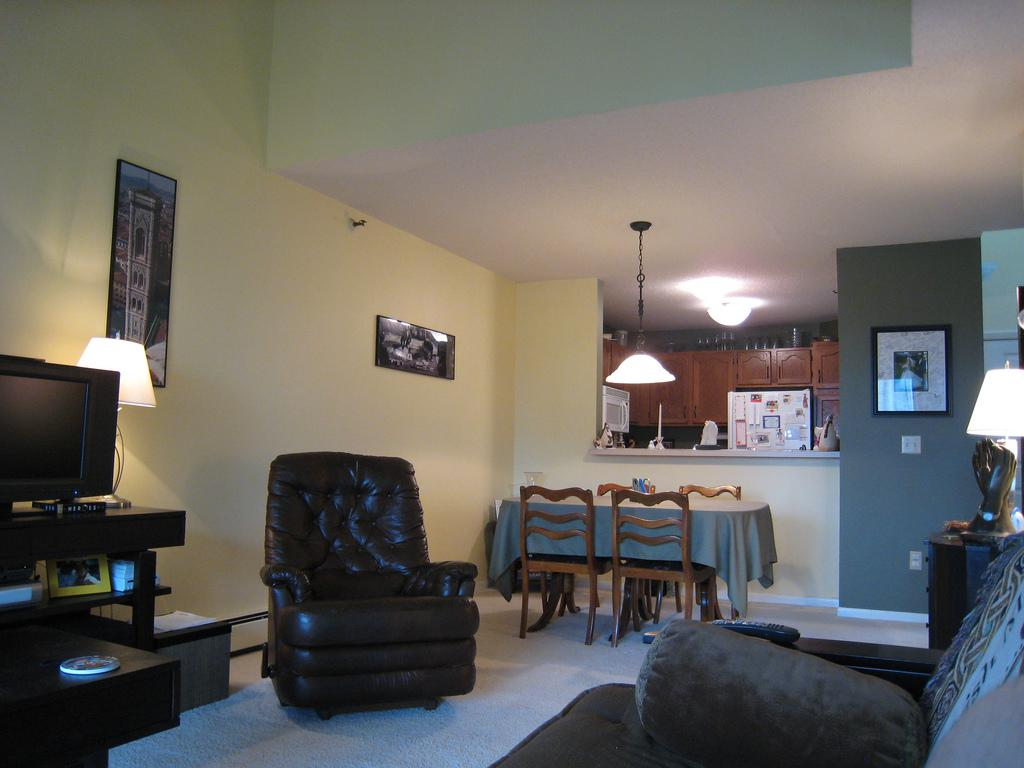Question: where is in the family room?
Choices:
A. A desk.
B. A stool.
C. A chair.
D. An oven.
Answer with the letter. Answer: C Question: how the family room look?
Choices:
A. Tidy.
B. Dirty.
C. Un arranged.
D. Clean.
Answer with the letter. Answer: D Question: what is in the family room?
Choices:
A. A bed.
B. A couch.
C. A computer.
D. A phone.
Answer with the letter. Answer: B Question: what is the color of the table cloth?
Choices:
A. Blue.
B. Pink.
C. White.
D. Green.
Answer with the letter. Answer: D Question: who is in the family room?
Choices:
A. Children.
B. Not one person.
C. Adults.
D. A family.
Answer with the letter. Answer: B Question: what is the kitchen light flush against?
Choices:
A. The wall.
B. The switch.
C. The fan.
D. The ceiling.
Answer with the letter. Answer: D Question: what room is the living room next to?
Choices:
A. The dining room.
B. The kitchen.
C. The laundry room.
D. The foyer.
Answer with the letter. Answer: A Question: how would you describe the living room?
Choices:
A. Large and open.
B. Small and cramped.
C. Small, clean and cozy.
D. Large and decorated.
Answer with the letter. Answer: C Question: where are the light switches?
Choices:
A. On three walls.
B. By the kitchen.
C. By the front door.
D. On one wall.
Answer with the letter. Answer: D Question: how many chairs are at the dining table?
Choices:
A. Three.
B. Four.
C. Two.
D. One.
Answer with the letter. Answer: B Question: what kind of lamps?
Choices:
A. Floor.
B. Desk.
C. Table.
D. Overhead.
Answer with the letter. Answer: C Question: what hangs on a cord?
Choices:
A. Mobile.
B. Light fixture.
C. Planter.
D. Disco ball.
Answer with the letter. Answer: B Question: how many pictures?
Choices:
A. Three.
B. Four.
C. Five.
D. Six.
Answer with the letter. Answer: A Question: what is on?
Choices:
A. The TV.
B. The oven.
C. The computer.
D. Lamps.
Answer with the letter. Answer: D Question: what color is the carpet?
Choices:
A. Blue.
B. White.
C. Red.
D. Beige.
Answer with the letter. Answer: B Question: what colors are the walls painted?
Choices:
A. The walls are painted purple and teal.
B. Grey, white, and light yellow.
C. The walls are painted red.
D. The walls are painted green.
Answer with the letter. Answer: B Question: what type of seat does the living room have?
Choices:
A. A recliner.
B. A sofa.
C. A futon.
D. A leather chair.
Answer with the letter. Answer: A Question: what color frame is the square picture in?
Choices:
A. Brown.
B. White.
C. Blue.
D. Black.
Answer with the letter. Answer: D Question: how many long skinny pictures hang on the walls?
Choices:
A. One.
B. Three.
C. Two.
D. Four.
Answer with the letter. Answer: C 